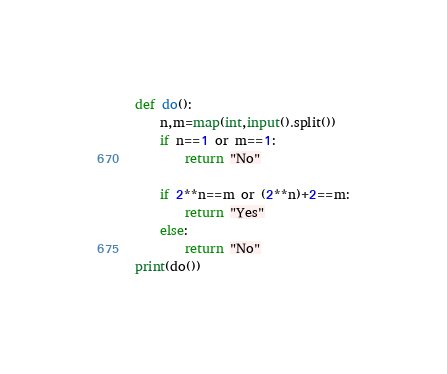Convert code to text. <code><loc_0><loc_0><loc_500><loc_500><_Python_>def do():
    n,m=map(int,input().split())
    if n==1 or m==1:
        return "No"

    if 2**n==m or (2**n)+2==m:
        return "Yes"
    else:
        return "No"
print(do())</code> 